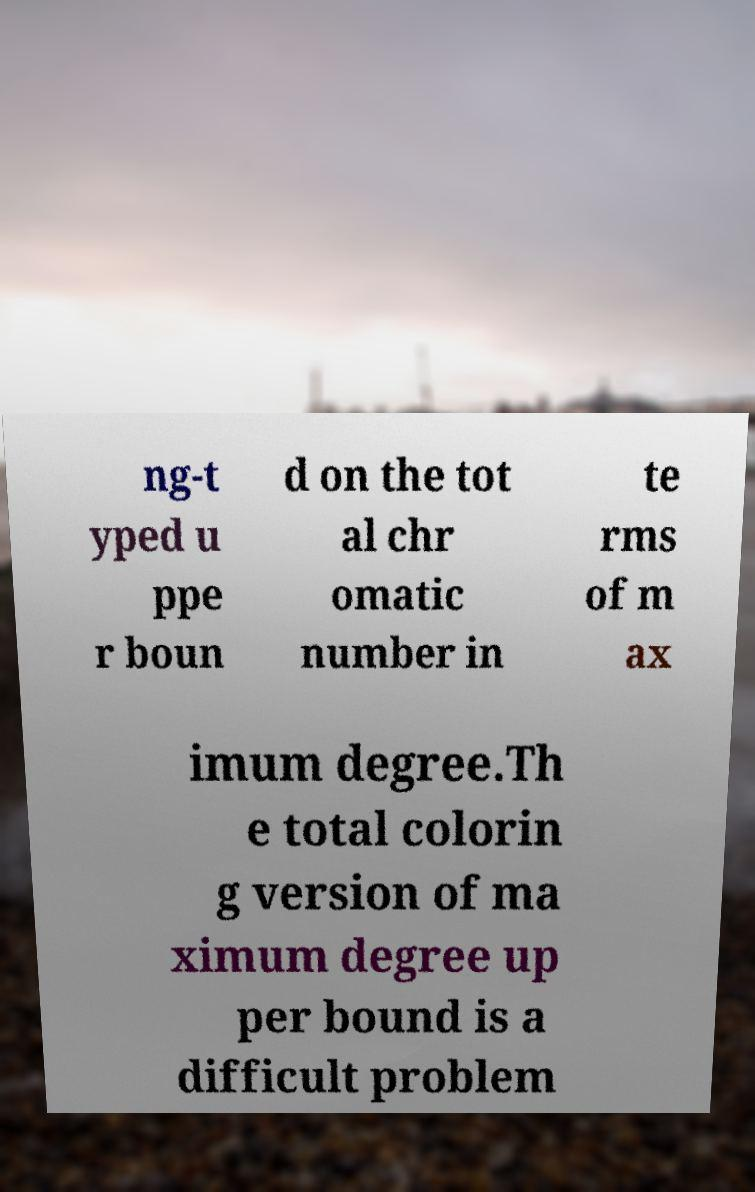There's text embedded in this image that I need extracted. Can you transcribe it verbatim? ng-t yped u ppe r boun d on the tot al chr omatic number in te rms of m ax imum degree.Th e total colorin g version of ma ximum degree up per bound is a difficult problem 